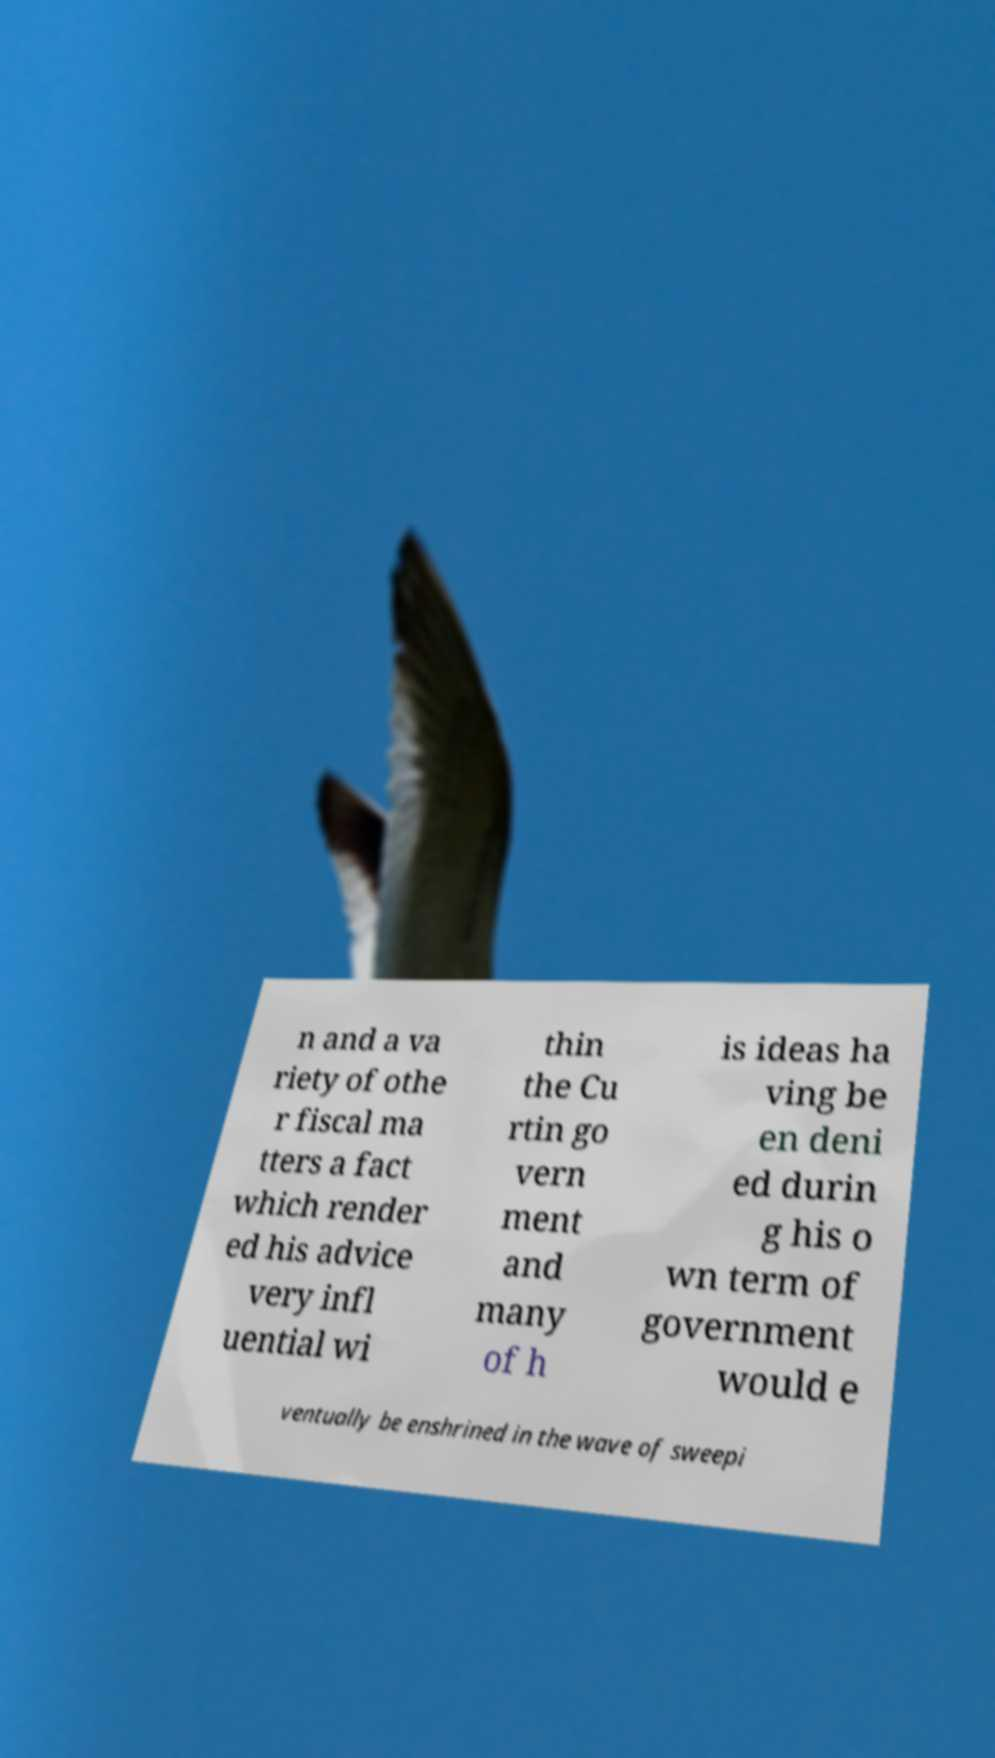Please identify and transcribe the text found in this image. n and a va riety of othe r fiscal ma tters a fact which render ed his advice very infl uential wi thin the Cu rtin go vern ment and many of h is ideas ha ving be en deni ed durin g his o wn term of government would e ventually be enshrined in the wave of sweepi 